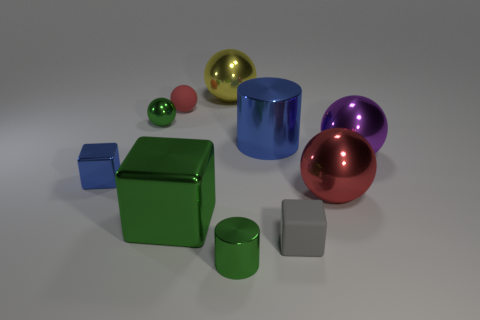What shape is the large blue thing that is made of the same material as the purple ball?
Your response must be concise. Cylinder. Does the yellow sphere have the same size as the green cylinder?
Provide a succinct answer. No. Are there any metal balls that have the same color as the small metallic block?
Your answer should be compact. No. How many objects are either green shiny things or red balls on the left side of the small gray matte block?
Your answer should be compact. 4. Is the number of large purple spheres greater than the number of small cyan metallic balls?
Give a very brief answer. Yes. The metallic ball that is the same color as the big block is what size?
Your answer should be compact. Small. Is there a big green cube that has the same material as the small cylinder?
Provide a succinct answer. Yes. What is the shape of the metallic object that is both behind the large red metal thing and on the right side of the gray rubber object?
Ensure brevity in your answer.  Sphere. What number of other objects are the same shape as the large red object?
Keep it short and to the point. 4. The yellow shiny sphere has what size?
Ensure brevity in your answer.  Large. 